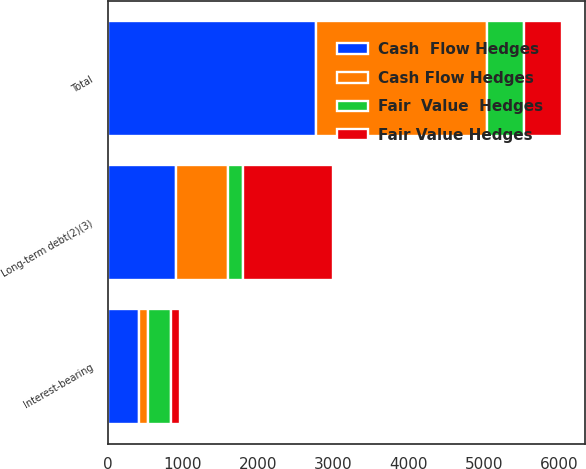Convert chart. <chart><loc_0><loc_0><loc_500><loc_500><stacked_bar_chart><ecel><fcel>Interest-bearing<fcel>Long-term debt(2)(3)<fcel>Total<nl><fcel>Cash Flow Hedges<fcel>118<fcel>700<fcel>2270<nl><fcel>Fair  Value  Hedges<fcel>300<fcel>200<fcel>500<nl><fcel>Cash  Flow Hedges<fcel>418<fcel>900<fcel>2770<nl><fcel>Fair Value Hedges<fcel>118<fcel>1200<fcel>500<nl></chart> 